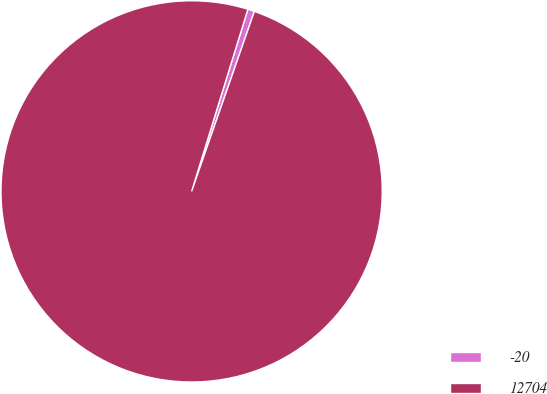Convert chart. <chart><loc_0><loc_0><loc_500><loc_500><pie_chart><fcel>-20<fcel>12704<nl><fcel>0.57%<fcel>99.43%<nl></chart> 